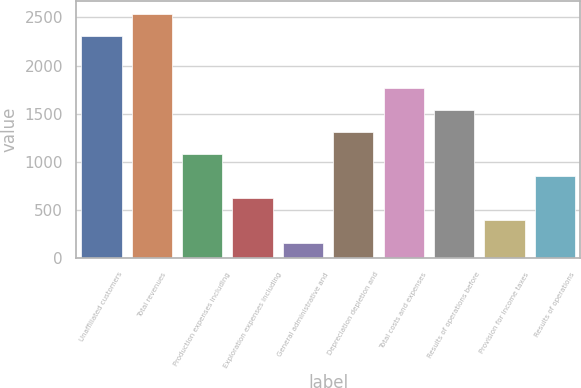<chart> <loc_0><loc_0><loc_500><loc_500><bar_chart><fcel>Unaffiliated customers<fcel>Total revenues<fcel>Production expenses including<fcel>Exploration expenses including<fcel>General administrative and<fcel>Depreciation depletion and<fcel>Total costs and expenses<fcel>Results of operations before<fcel>Provision for income taxes<fcel>Results of operations<nl><fcel>2310<fcel>2539.2<fcel>1077.8<fcel>619.4<fcel>161<fcel>1307<fcel>1765.4<fcel>1536.2<fcel>390.2<fcel>848.6<nl></chart> 